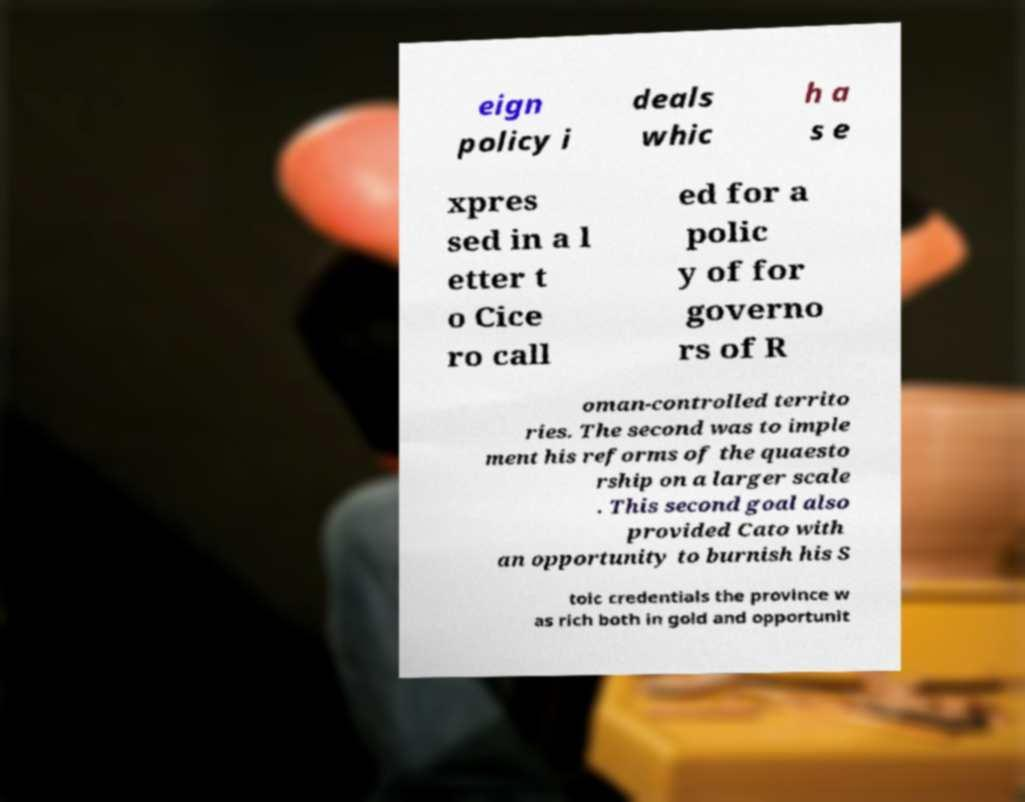Could you extract and type out the text from this image? eign policy i deals whic h a s e xpres sed in a l etter t o Cice ro call ed for a polic y of for governo rs of R oman-controlled territo ries. The second was to imple ment his reforms of the quaesto rship on a larger scale . This second goal also provided Cato with an opportunity to burnish his S toic credentials the province w as rich both in gold and opportunit 